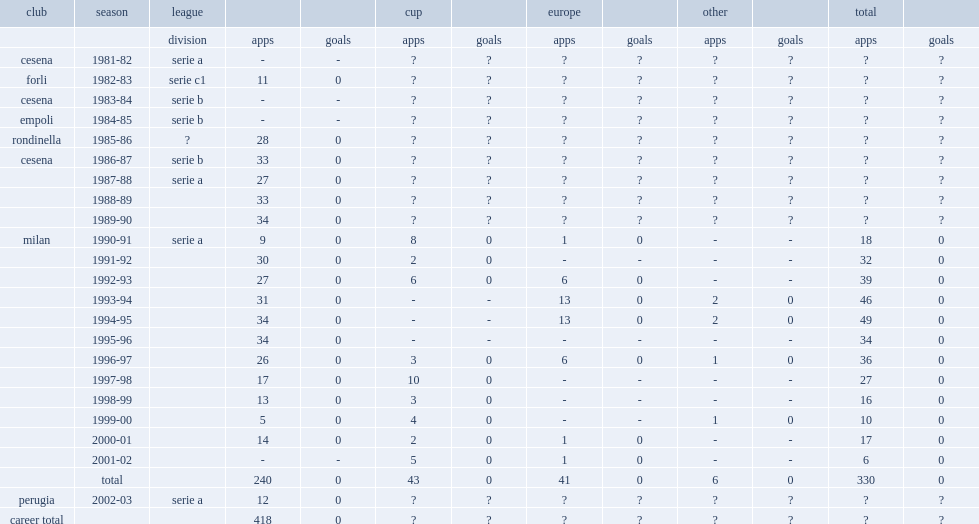In 1982-83, which league did sebastiano rossi appear for forli? Serie c1. 